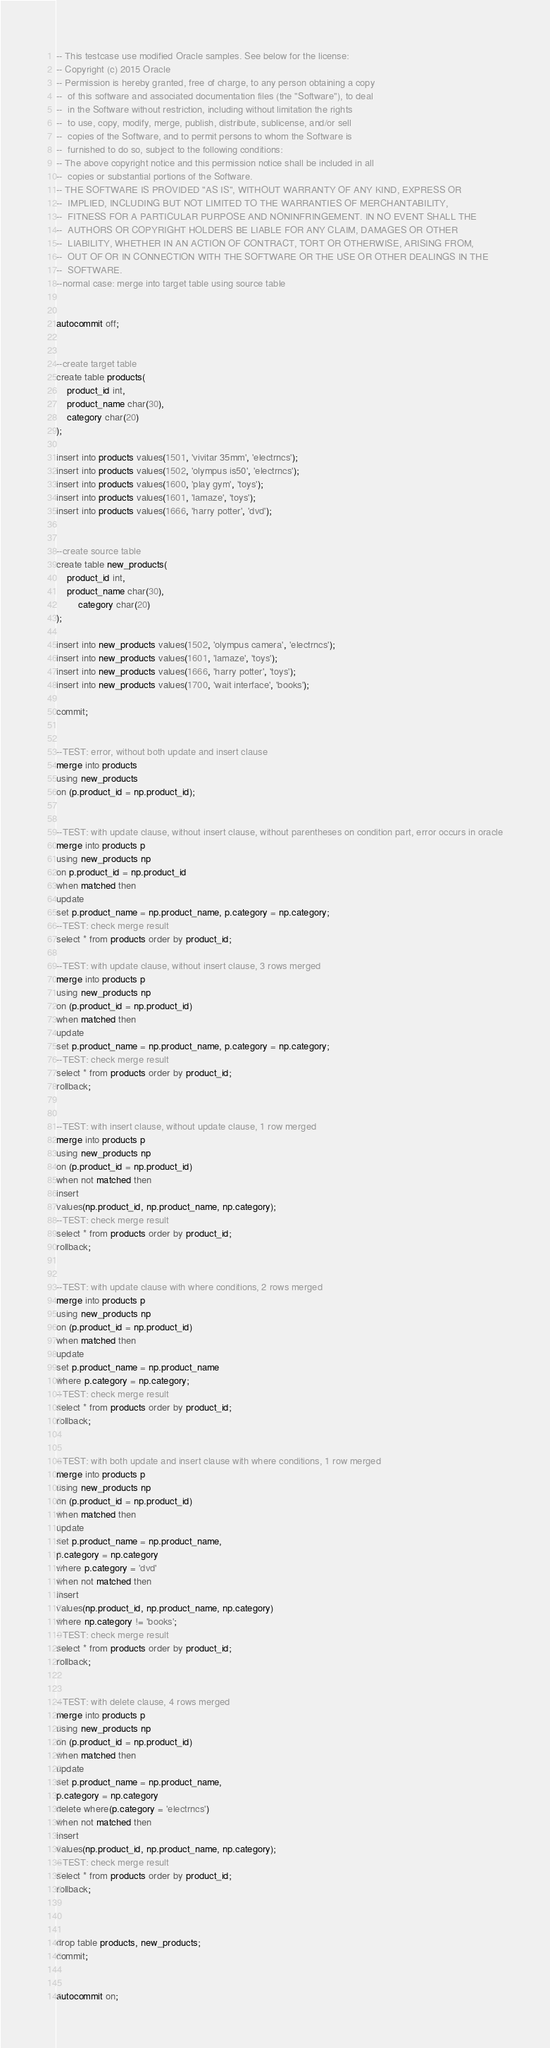<code> <loc_0><loc_0><loc_500><loc_500><_SQL_>-- This testcase use modified Oracle samples. See below for the license:
-- Copyright (c) 2015 Oracle
-- Permission is hereby granted, free of charge, to any person obtaining a copy
--  of this software and associated documentation files (the "Software"), to deal
--  in the Software without restriction, including without limitation the rights
--  to use, copy, modify, merge, publish, distribute, sublicense, and/or sell
--  copies of the Software, and to permit persons to whom the Software is
--  furnished to do so, subject to the following conditions:
-- The above copyright notice and this permission notice shall be included in all
--  copies or substantial portions of the Software.
-- THE SOFTWARE IS PROVIDED "AS IS", WITHOUT WARRANTY OF ANY KIND, EXPRESS OR
--  IMPLIED, INCLUDING BUT NOT LIMITED TO THE WARRANTIES OF MERCHANTABILITY,
--  FITNESS FOR A PARTICULAR PURPOSE AND NONINFRINGEMENT. IN NO EVENT SHALL THE
--  AUTHORS OR COPYRIGHT HOLDERS BE LIABLE FOR ANY CLAIM, DAMAGES OR OTHER
--  LIABILITY, WHETHER IN AN ACTION OF CONTRACT, TORT OR OTHERWISE, ARISING FROM,
--  OUT OF OR IN CONNECTION WITH THE SOFTWARE OR THE USE OR OTHER DEALINGS IN THE
--  SOFTWARE.
--normal case: merge into target table using source table


autocommit off;


--create target table
create table products(
	product_id int,
	product_name char(30),
	category char(20)
);

insert into products values(1501, 'vivitar 35mm', 'electrncs');
insert into products values(1502, 'olympus is50', 'electrncs');
insert into products values(1600, 'play gym', 'toys');
insert into products values(1601, 'lamaze', 'toys');
insert into products values(1666, 'harry potter', 'dvd');


--create source table
create table new_products(
	product_id int,
	product_name char(30),
        category char(20)
);

insert into new_products values(1502, 'olympus camera', 'electrncs');
insert into new_products values(1601, 'lamaze', 'toys');
insert into new_products values(1666, 'harry potter', 'toys');
insert into new_products values(1700, 'wait interface', 'books');

commit;


--TEST: error, without both update and insert clause
merge into products
using new_products
on (p.product_id = np.product_id);


--TEST: with update clause, without insert clause, without parentheses on condition part, error occurs in oracle
merge into products p
using new_products np
on p.product_id = np.product_id
when matched then
update
set p.product_name = np.product_name, p.category = np.category;
--TEST: check merge result
select * from products order by product_id;

--TEST: with update clause, without insert clause, 3 rows merged
merge into products p
using new_products np
on (p.product_id = np.product_id)
when matched then
update
set p.product_name = np.product_name, p.category = np.category;
--TEST: check merge result
select * from products order by product_id;
rollback;


--TEST: with insert clause, without update clause, 1 row merged
merge into products p
using new_products np
on (p.product_id = np.product_id)
when not matched then
insert
values(np.product_id, np.product_name, np.category);
--TEST: check merge result
select * from products order by product_id;
rollback;


--TEST: with update clause with where conditions, 2 rows merged
merge into products p
using new_products np
on (p.product_id = np.product_id)
when matched then
update
set p.product_name = np.product_name
where p.category = np.category; 
--TEST: check merge result
select * from products order by product_id;
rollback;


--TEST: with both update and insert clause with where conditions, 1 row merged
merge into products p
using new_products np
on (p.product_id = np.product_id)
when matched then
update
set p.product_name = np.product_name,
p.category = np.category
where p.category = 'dvd'
when not matched then
insert 
values(np.product_id, np.product_name, np.category)
where np.category != 'books';
--TEST: check merge result
select * from products order by product_id;
rollback;


--TEST: with delete clause, 4 rows merged
merge into products p
using new_products np
on (p.product_id = np.product_id)
when matched then
update
set p.product_name = np.product_name,
p.category = np.category
delete where(p.category = 'electrncs')
when not matched then
insert
values(np.product_id, np.product_name, np.category);
--TEST: check merge result
select * from products order by product_id;
rollback;



drop table products, new_products;
commit;


autocommit on;
</code> 